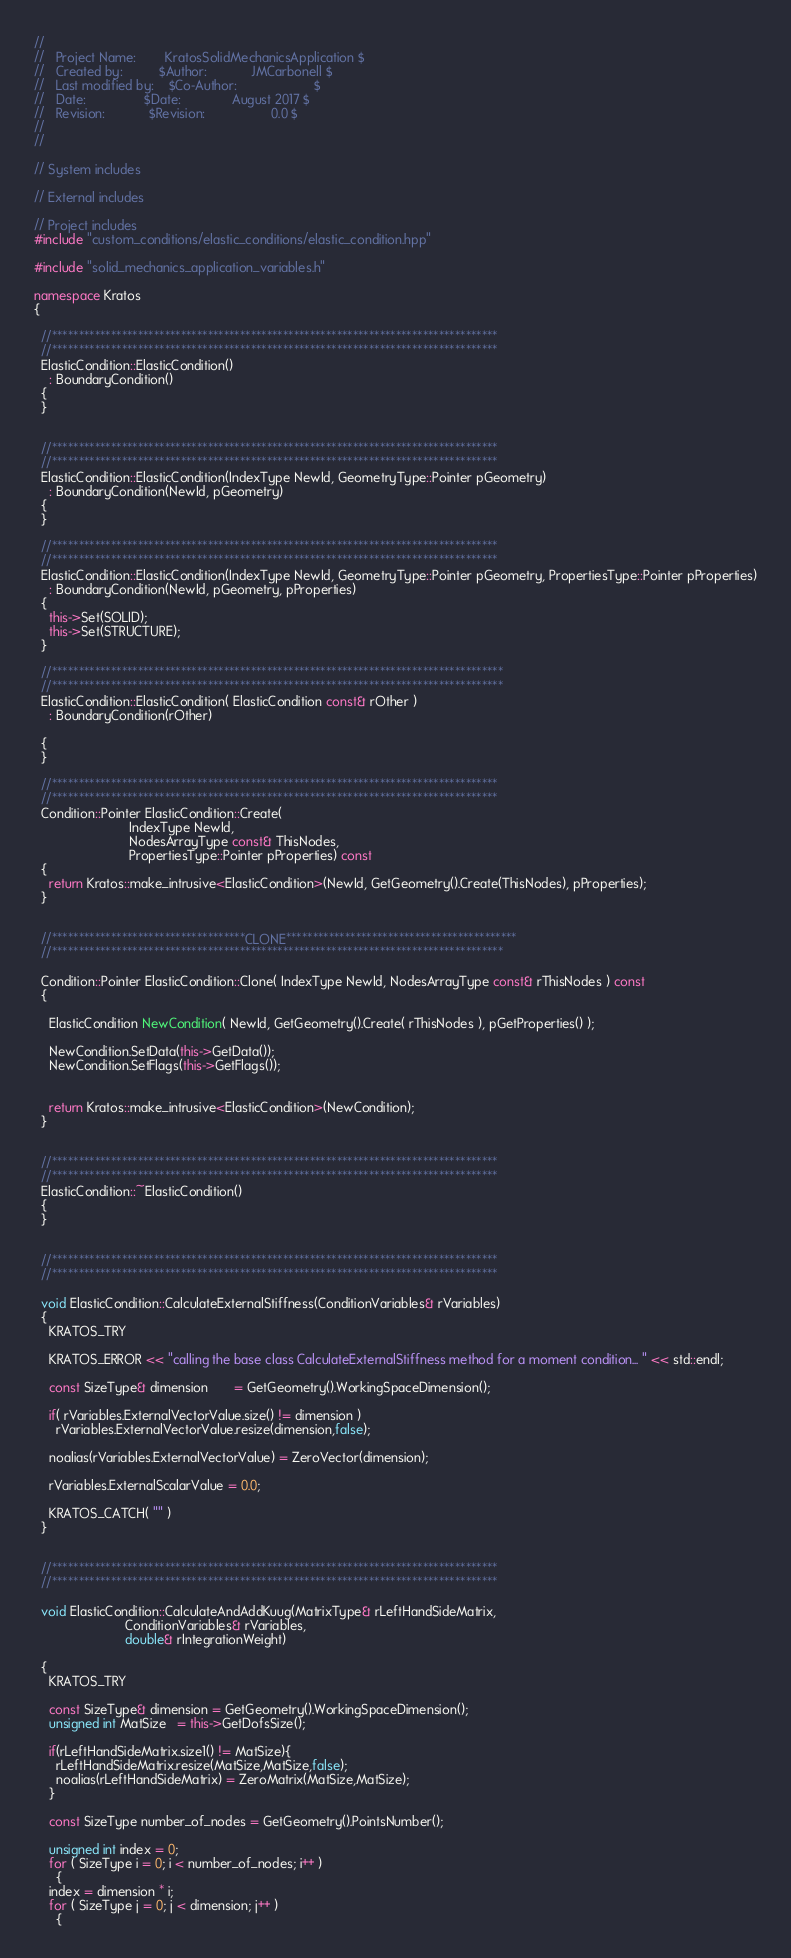Convert code to text. <code><loc_0><loc_0><loc_500><loc_500><_C++_>//
//   Project Name:        KratosSolidMechanicsApplication $
//   Created by:          $Author:            JMCarbonell $
//   Last modified by:    $Co-Author:                     $
//   Date:                $Date:              August 2017 $
//   Revision:            $Revision:                  0.0 $
//
//

// System includes

// External includes

// Project includes
#include "custom_conditions/elastic_conditions/elastic_condition.hpp"

#include "solid_mechanics_application_variables.h"

namespace Kratos
{

  //***********************************************************************************
  //***********************************************************************************
  ElasticCondition::ElasticCondition()
    : BoundaryCondition()
  {
  }


  //***********************************************************************************
  //***********************************************************************************
  ElasticCondition::ElasticCondition(IndexType NewId, GeometryType::Pointer pGeometry)
    : BoundaryCondition(NewId, pGeometry)
  {
  }

  //***********************************************************************************
  //***********************************************************************************
  ElasticCondition::ElasticCondition(IndexType NewId, GeometryType::Pointer pGeometry, PropertiesType::Pointer pProperties)
    : BoundaryCondition(NewId, pGeometry, pProperties)
  {
    this->Set(SOLID);
    this->Set(STRUCTURE);
  }

  //************************************************************************************
  //************************************************************************************
  ElasticCondition::ElasticCondition( ElasticCondition const& rOther )
    : BoundaryCondition(rOther)

  {
  }

  //***********************************************************************************
  //***********************************************************************************
  Condition::Pointer ElasticCondition::Create(
					      IndexType NewId,
					      NodesArrayType const& ThisNodes,
					      PropertiesType::Pointer pProperties) const
  {
    return Kratos::make_intrusive<ElasticCondition>(NewId, GetGeometry().Create(ThisNodes), pProperties);
  }


  //************************************CLONE*******************************************
  //************************************************************************************

  Condition::Pointer ElasticCondition::Clone( IndexType NewId, NodesArrayType const& rThisNodes ) const
  {

    ElasticCondition NewCondition( NewId, GetGeometry().Create( rThisNodes ), pGetProperties() );

    NewCondition.SetData(this->GetData());
    NewCondition.SetFlags(this->GetFlags());


    return Kratos::make_intrusive<ElasticCondition>(NewCondition);
  }


  //***********************************************************************************
  //***********************************************************************************
  ElasticCondition::~ElasticCondition()
  {
  }


  //***********************************************************************************
  //***********************************************************************************

  void ElasticCondition::CalculateExternalStiffness(ConditionVariables& rVariables)
  {
    KRATOS_TRY

    KRATOS_ERROR << "calling the base class CalculateExternalStiffness method for a moment condition... " << std::endl;

    const SizeType& dimension       = GetGeometry().WorkingSpaceDimension();

    if( rVariables.ExternalVectorValue.size() != dimension )
      rVariables.ExternalVectorValue.resize(dimension,false);

    noalias(rVariables.ExternalVectorValue) = ZeroVector(dimension);

    rVariables.ExternalScalarValue = 0.0;

    KRATOS_CATCH( "" )
  }


  //***********************************************************************************
  //***********************************************************************************

  void ElasticCondition::CalculateAndAddKuug(MatrixType& rLeftHandSideMatrix,
					     ConditionVariables& rVariables,
					     double& rIntegrationWeight)

  {
    KRATOS_TRY

    const SizeType& dimension = GetGeometry().WorkingSpaceDimension();
    unsigned int MatSize   = this->GetDofsSize();

    if(rLeftHandSideMatrix.size1() != MatSize){
      rLeftHandSideMatrix.resize(MatSize,MatSize,false);
      noalias(rLeftHandSideMatrix) = ZeroMatrix(MatSize,MatSize);
    }

    const SizeType number_of_nodes = GetGeometry().PointsNumber();

    unsigned int index = 0;
    for ( SizeType i = 0; i < number_of_nodes; i++ )
      {
	index = dimension * i;
	for ( SizeType j = 0; j < dimension; j++ )
	  {</code> 